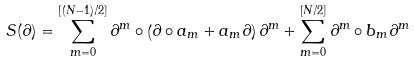<formula> <loc_0><loc_0><loc_500><loc_500>S ( \partial ) = \sum _ { m = 0 } ^ { [ ( N - 1 ) / 2 ] } \partial ^ { m } \circ \left ( \partial \circ a _ { m } + a _ { m } \partial \right ) \partial ^ { m } + \sum _ { m = 0 } ^ { [ N / 2 ] } \partial ^ { m } \circ b _ { m } \partial ^ { m }</formula> 